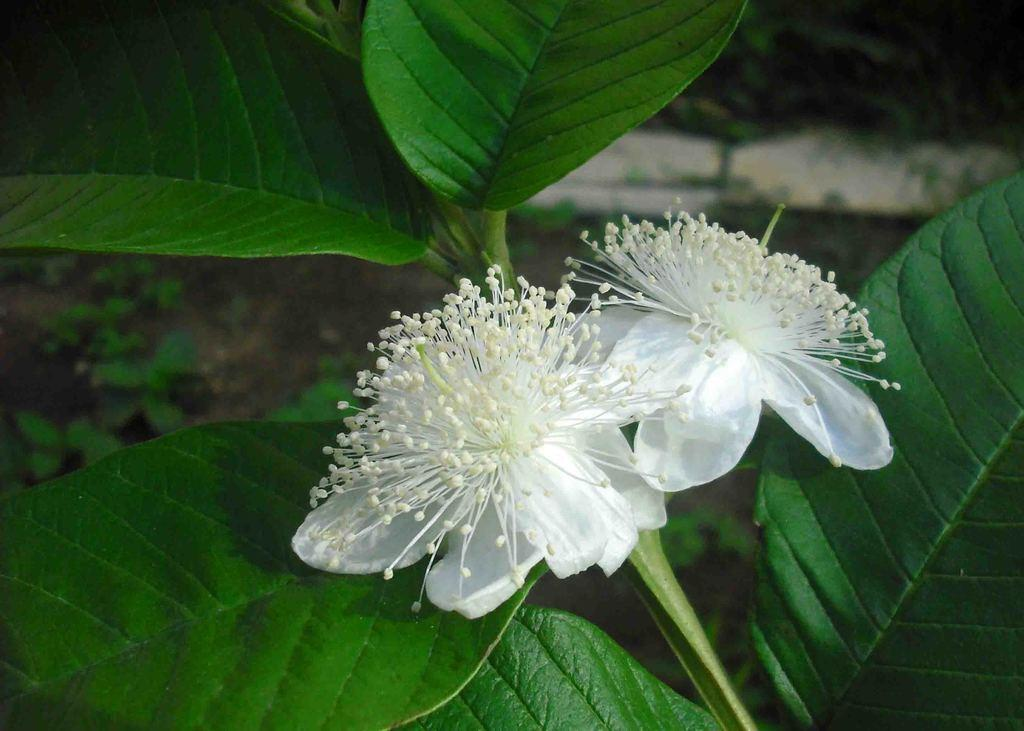What type of plant is featured in the image? There is a guava tree in the image. What can be found growing on the guava tree? There are two flowers on the guava tree in the image. What type of cable can be seen connecting the flowers on the guava tree? There is no cable connecting the flowers on the guava tree in the image. 